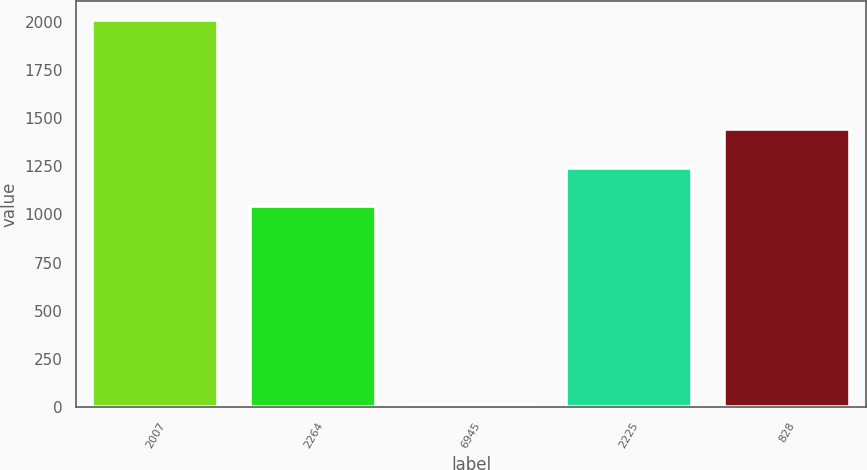Convert chart. <chart><loc_0><loc_0><loc_500><loc_500><bar_chart><fcel>2007<fcel>2264<fcel>6945<fcel>2225<fcel>828<nl><fcel>2006<fcel>1044<fcel>14<fcel>1243.2<fcel>1442.4<nl></chart> 